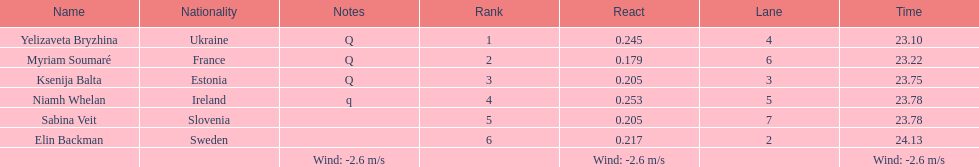How long did it take elin backman to finish the race? 24.13. 